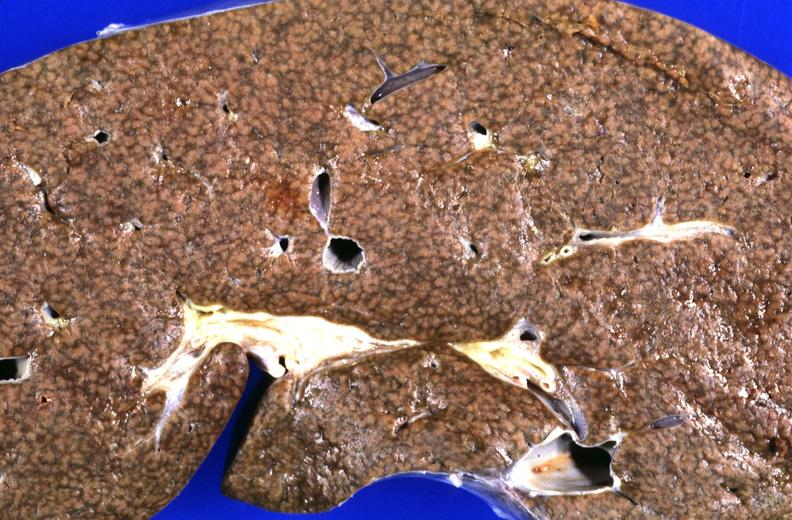does this image show liver, cirrhosis and iron overload, chronic sickle cell disease with multiple blood transfusions?
Answer the question using a single word or phrase. Yes 